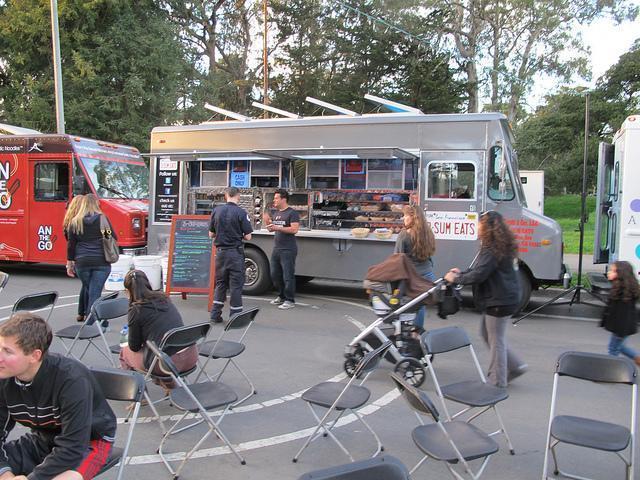How many people are occupying chairs in this picture?
Give a very brief answer. 2. How many autos are there?
Give a very brief answer. 3. How many people can be seen?
Give a very brief answer. 8. How many trucks are there?
Give a very brief answer. 3. How many chairs are in the picture?
Give a very brief answer. 5. How many apple brand laptops can you see?
Give a very brief answer. 0. 